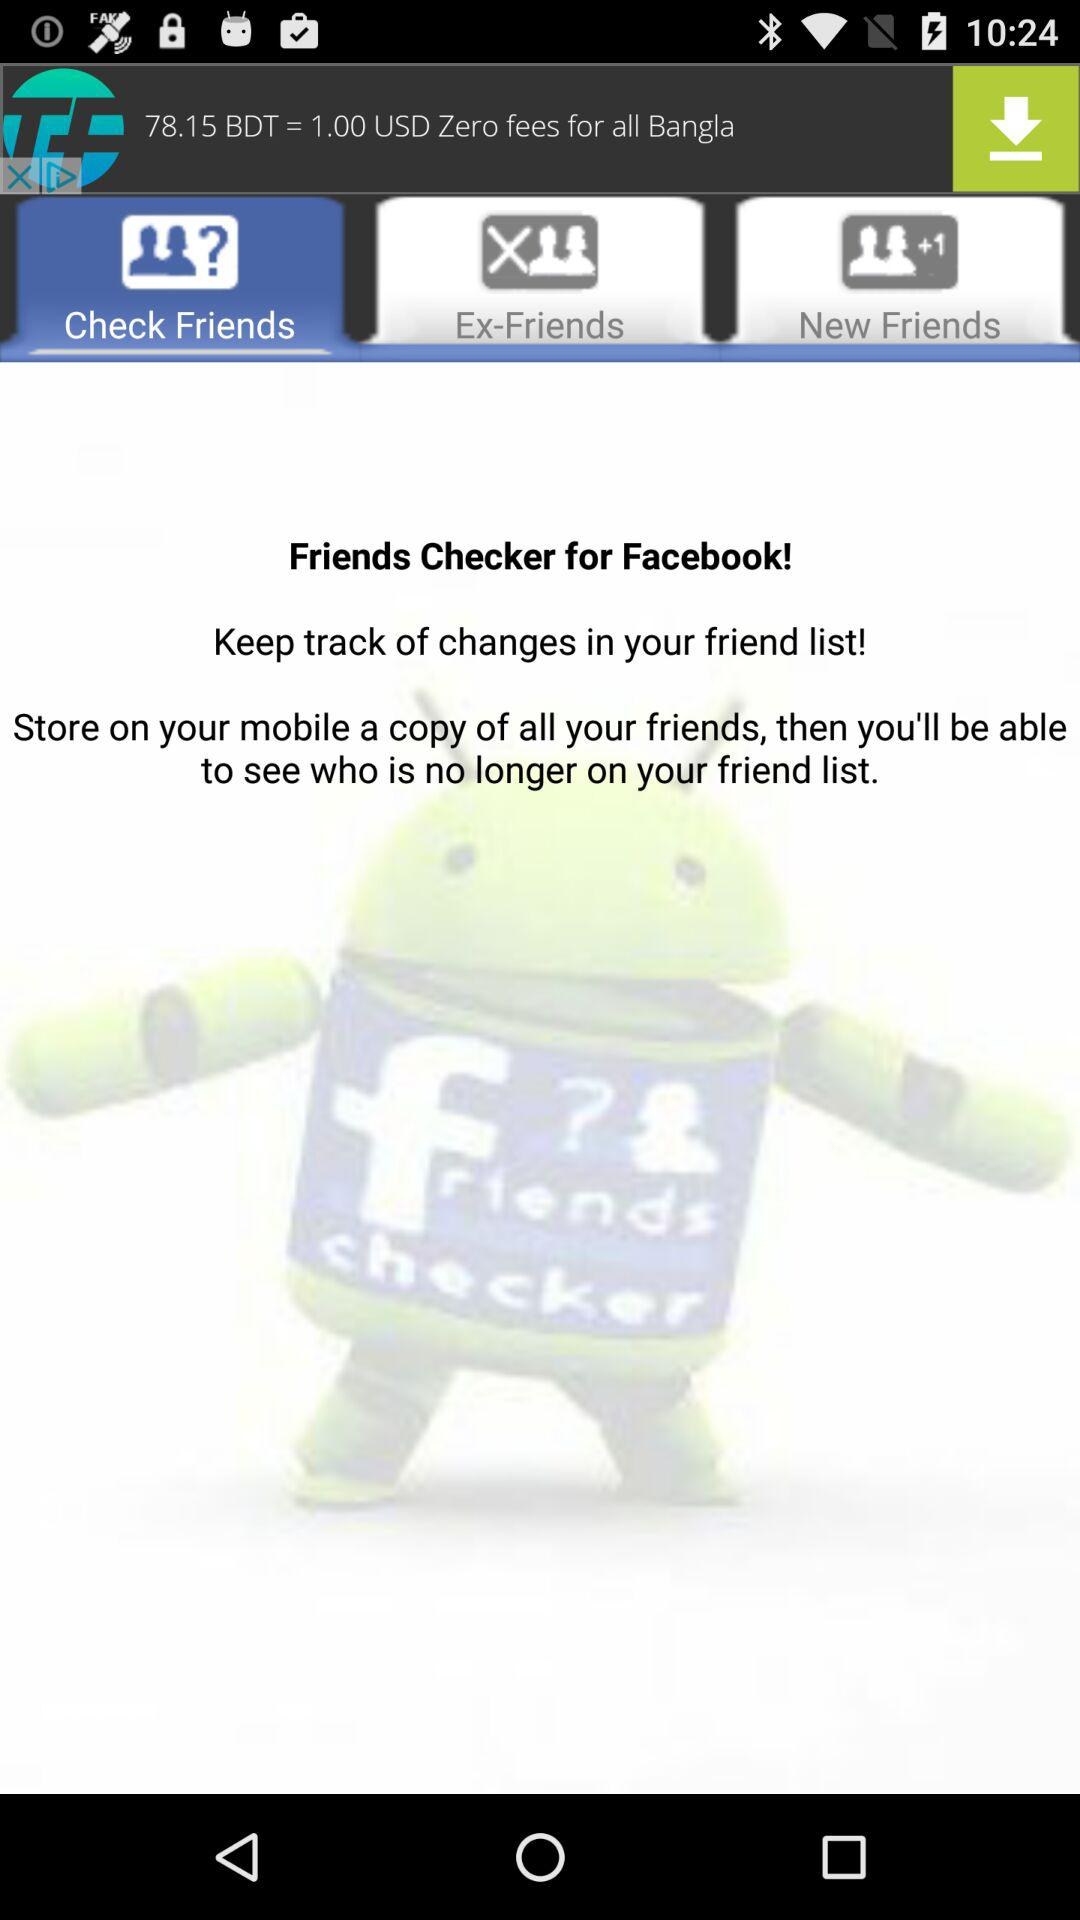Which tab am I using? You are using the "Check Friends" tab. 